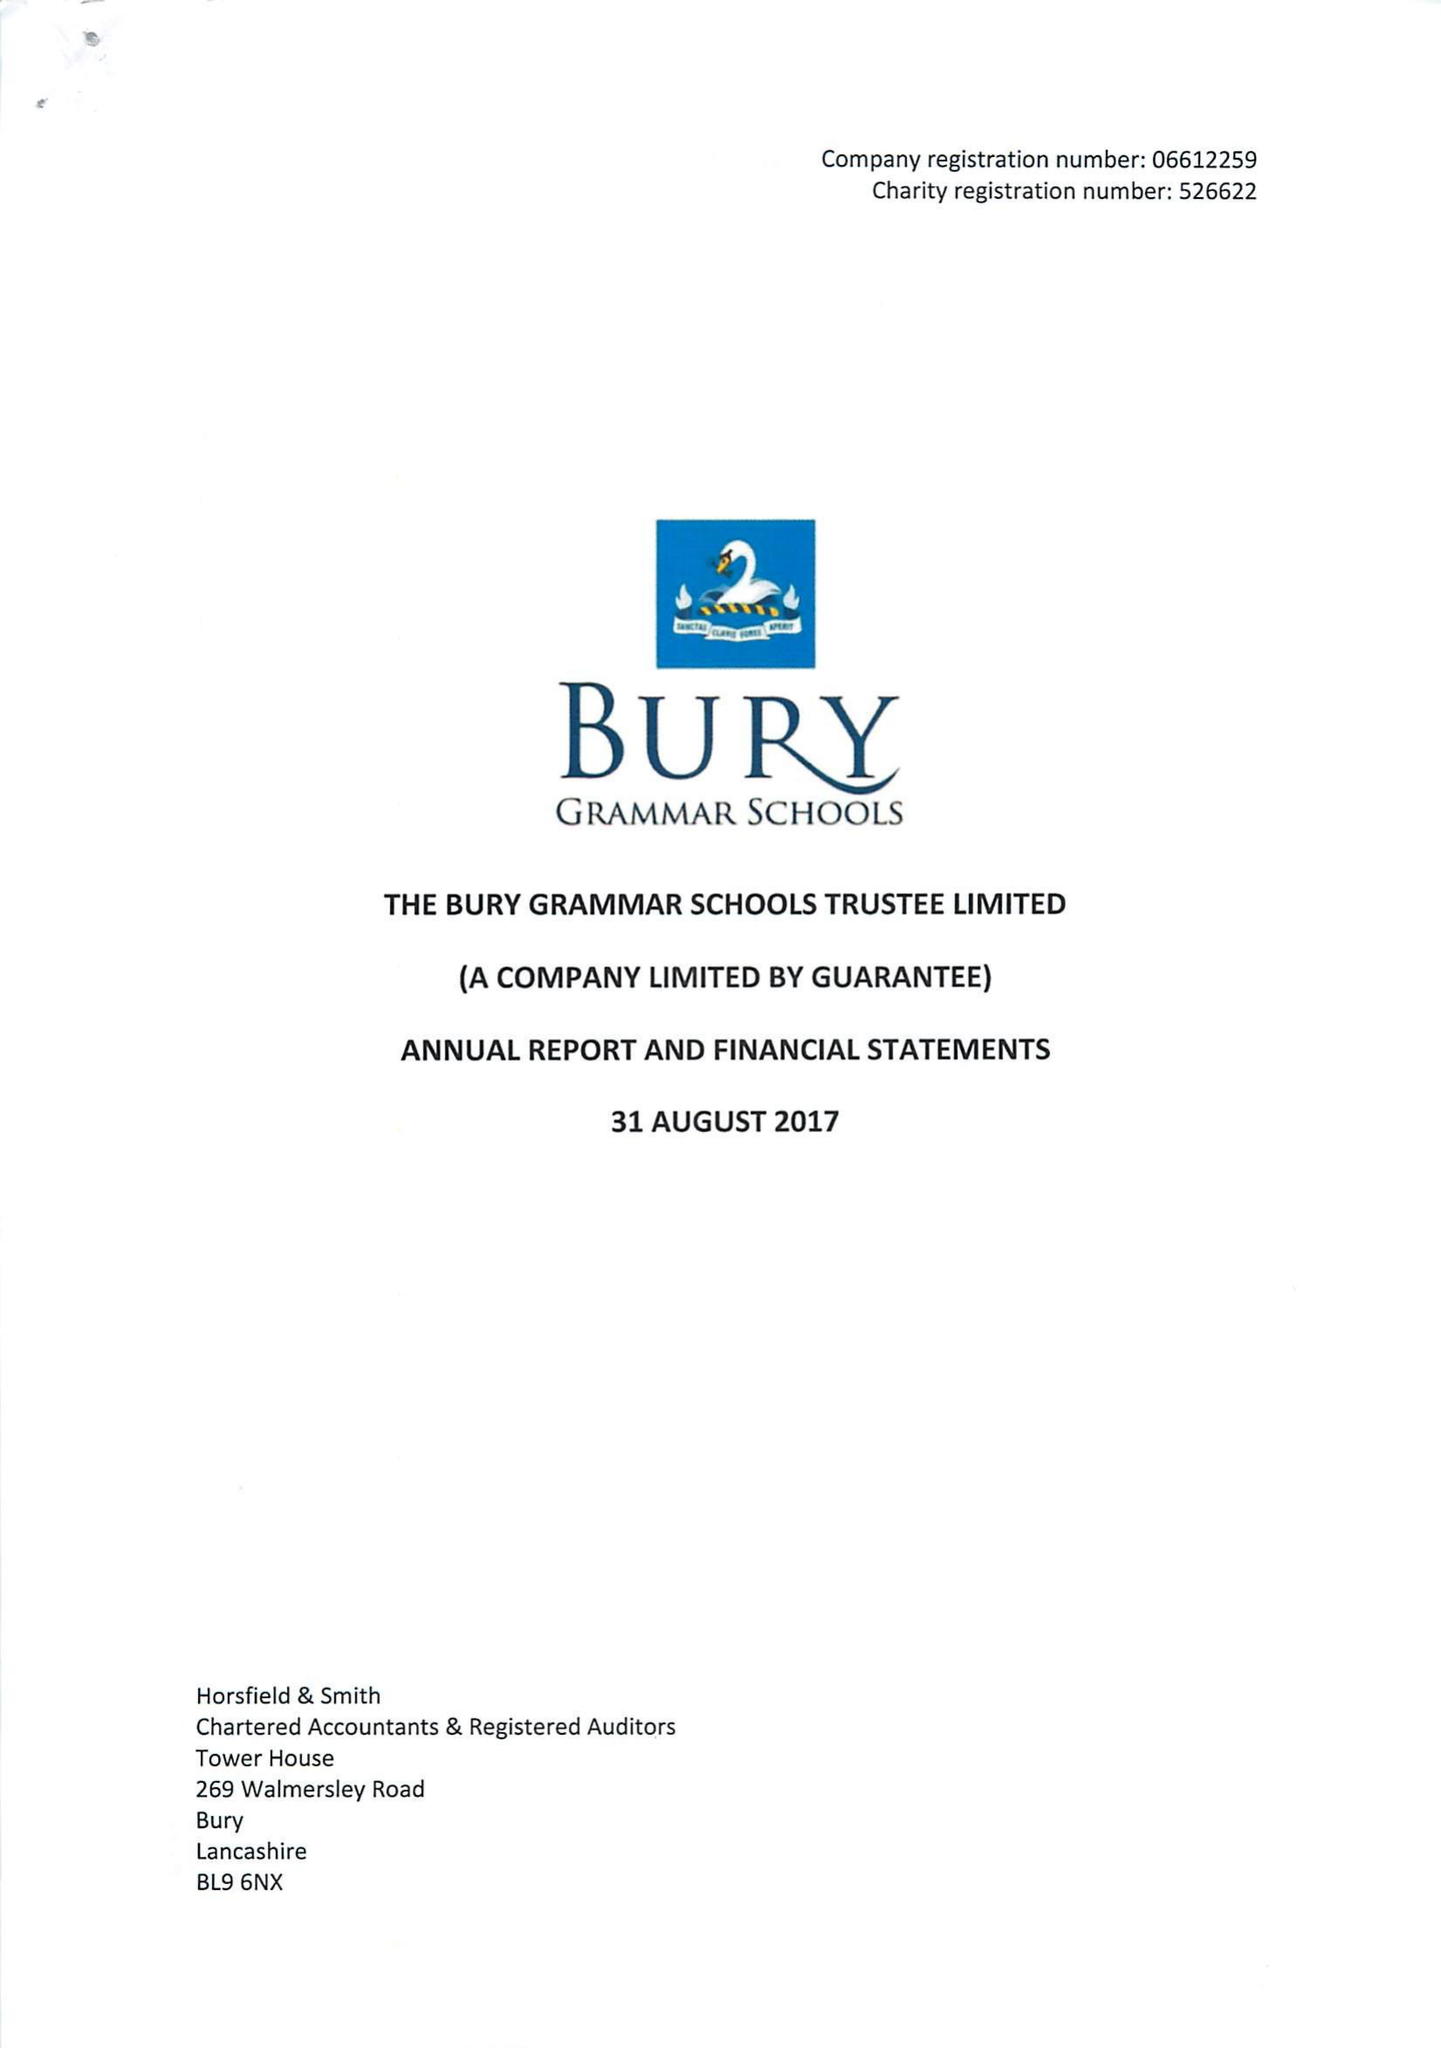What is the value for the spending_annually_in_british_pounds?
Answer the question using a single word or phrase. 11814000.00 